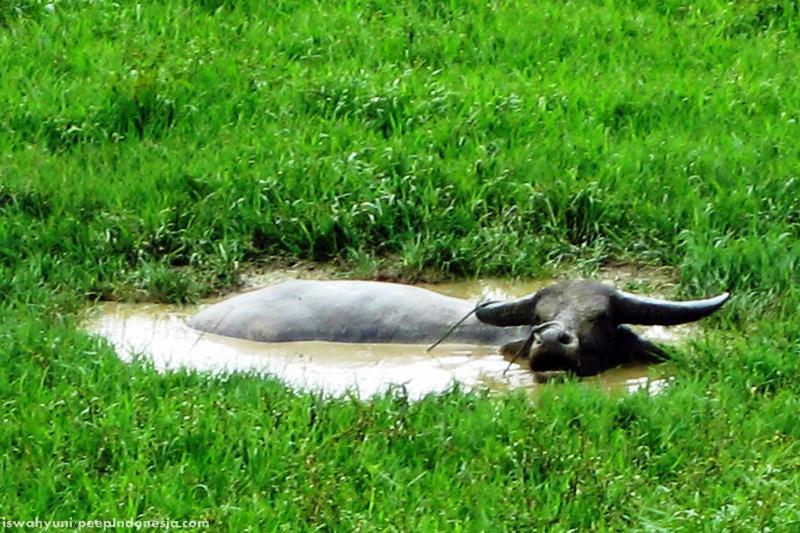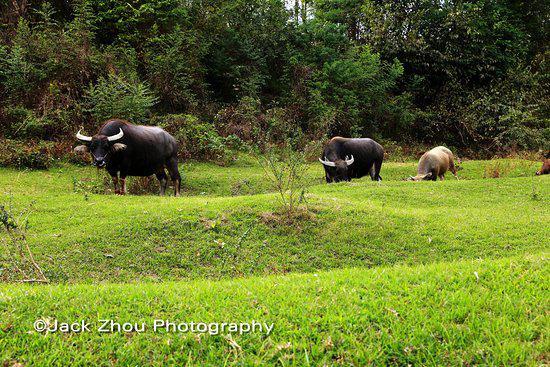The first image is the image on the left, the second image is the image on the right. Considering the images on both sides, is "The right image features at least one leftward-headed water buffalo standing in profile in water that reaches its belly." valid? Answer yes or no. No. The first image is the image on the left, the second image is the image on the right. Considering the images on both sides, is "The left and right image contains the same number black bulls." valid? Answer yes or no. No. 